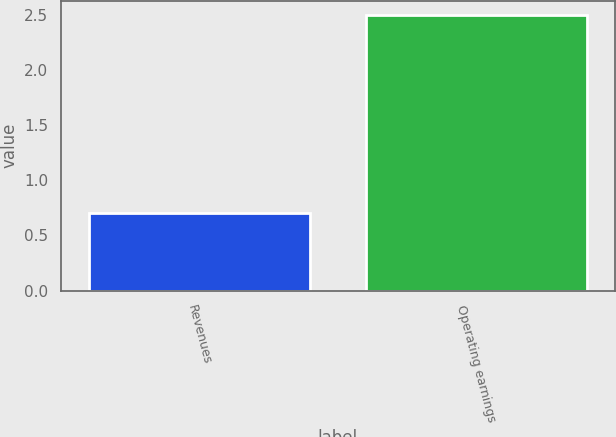Convert chart to OTSL. <chart><loc_0><loc_0><loc_500><loc_500><bar_chart><fcel>Revenues<fcel>Operating earnings<nl><fcel>0.7<fcel>2.5<nl></chart> 